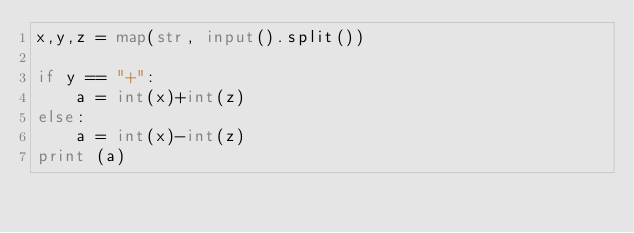Convert code to text. <code><loc_0><loc_0><loc_500><loc_500><_Python_>x,y,z = map(str, input().split())

if y == "+":
    a = int(x)+int(z)
else:
    a = int(x)-int(z)
print (a)</code> 